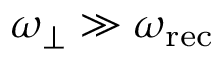Convert formula to latex. <formula><loc_0><loc_0><loc_500><loc_500>\omega _ { \perp } \gg \omega _ { r e c }</formula> 